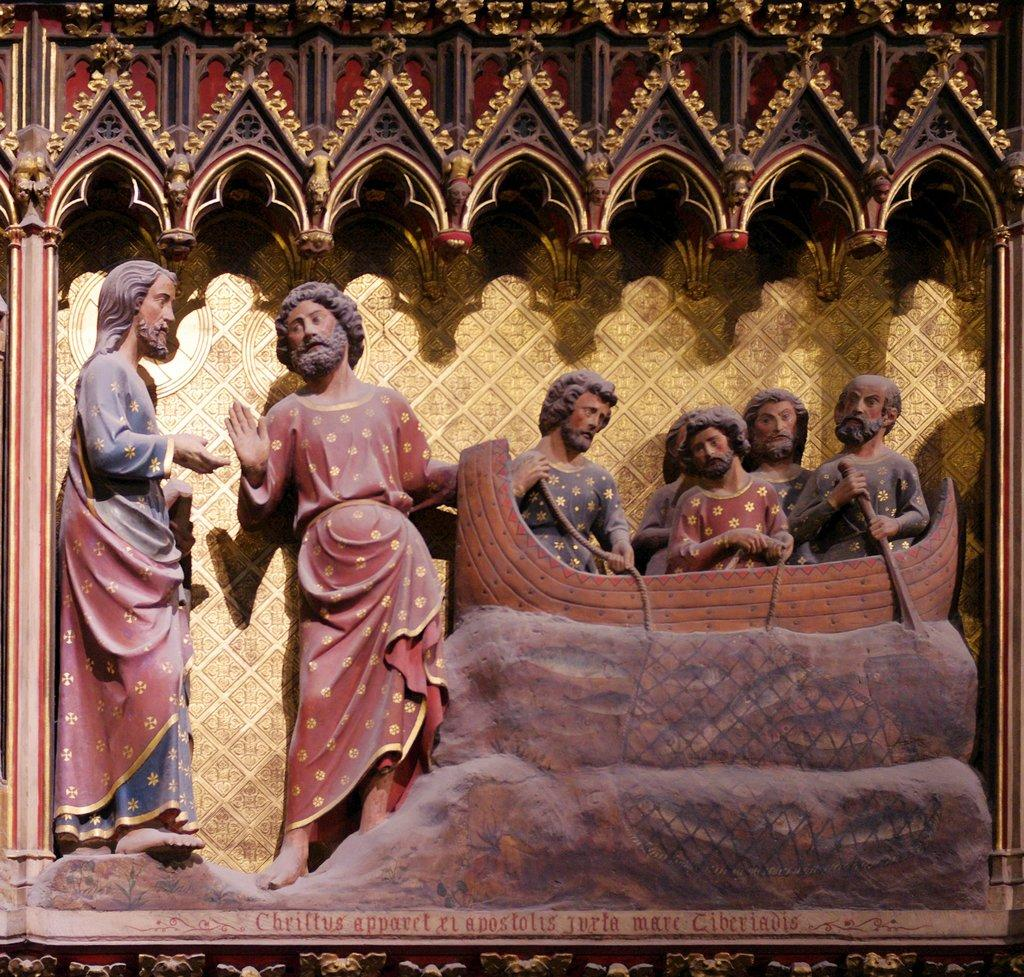What is depicted in the sculpture in the image? There is a sculpture of two persons standing in the image. What activity are the people in the image engaged in? The people are sitting in a boat in the image. What is the color of the boat? The boat is brown in color. What can be seen in the background of the image? There is a gold-colored surface in the background of the image. How does the flame affect the scale in the image? There is no flame present in the image, so it cannot affect the scale. 